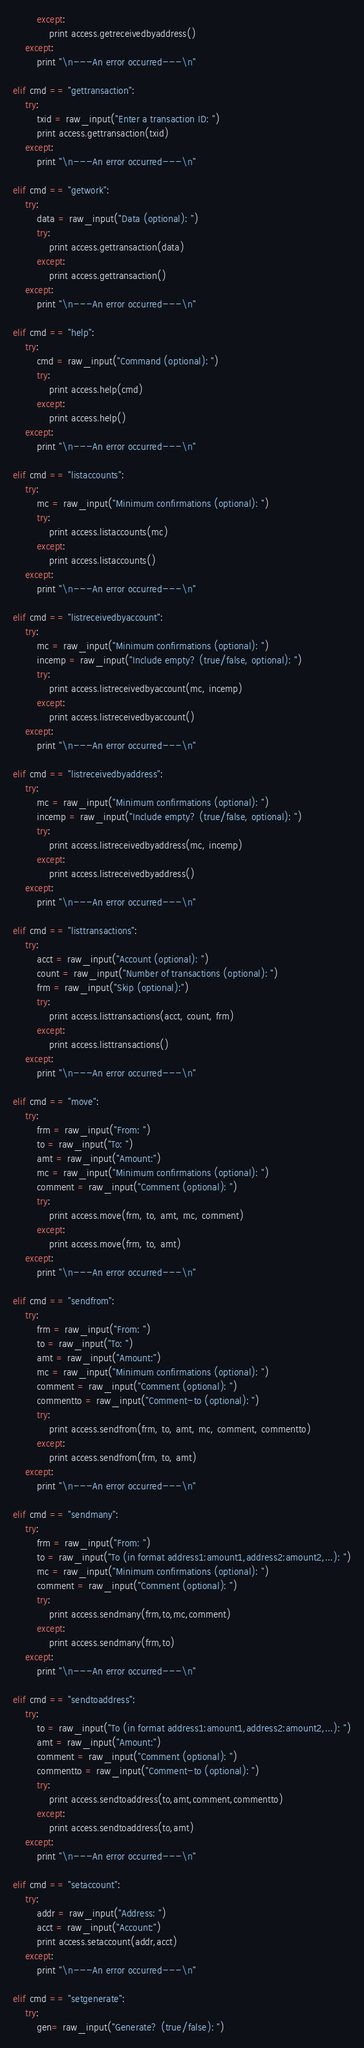Convert code to text. <code><loc_0><loc_0><loc_500><loc_500><_Python_>        except:
            print access.getreceivedbyaddress()
    except:
        print "\n---An error occurred---\n"

elif cmd == "gettransaction":
    try:
        txid = raw_input("Enter a transaction ID: ")
        print access.gettransaction(txid)
    except:
        print "\n---An error occurred---\n"

elif cmd == "getwork":
    try:
        data = raw_input("Data (optional): ")
        try:
            print access.gettransaction(data)
        except:
            print access.gettransaction()
    except:
        print "\n---An error occurred---\n"

elif cmd == "help":
    try:
        cmd = raw_input("Command (optional): ")
        try:
            print access.help(cmd)
        except:
            print access.help()
    except:
        print "\n---An error occurred---\n"

elif cmd == "listaccounts":
    try:
        mc = raw_input("Minimum confirmations (optional): ")
        try:
            print access.listaccounts(mc)
        except:
            print access.listaccounts()
    except:
        print "\n---An error occurred---\n"

elif cmd == "listreceivedbyaccount":
    try:
        mc = raw_input("Minimum confirmations (optional): ")
        incemp = raw_input("Include empty? (true/false, optional): ")
        try:
            print access.listreceivedbyaccount(mc, incemp)
        except:
            print access.listreceivedbyaccount()
    except:
        print "\n---An error occurred---\n"

elif cmd == "listreceivedbyaddress":
    try:
        mc = raw_input("Minimum confirmations (optional): ")
        incemp = raw_input("Include empty? (true/false, optional): ")
        try:
            print access.listreceivedbyaddress(mc, incemp)
        except:
            print access.listreceivedbyaddress()
    except:
        print "\n---An error occurred---\n"

elif cmd == "listtransactions":
    try:
        acct = raw_input("Account (optional): ")
        count = raw_input("Number of transactions (optional): ")
        frm = raw_input("Skip (optional):")
        try:
            print access.listtransactions(acct, count, frm)
        except:
            print access.listtransactions()
    except:
        print "\n---An error occurred---\n"

elif cmd == "move":
    try:
        frm = raw_input("From: ")
        to = raw_input("To: ")
        amt = raw_input("Amount:")
        mc = raw_input("Minimum confirmations (optional): ")
        comment = raw_input("Comment (optional): ")
        try:
            print access.move(frm, to, amt, mc, comment)
        except:
            print access.move(frm, to, amt)
    except:
        print "\n---An error occurred---\n"

elif cmd == "sendfrom":
    try:
        frm = raw_input("From: ")
        to = raw_input("To: ")
        amt = raw_input("Amount:")
        mc = raw_input("Minimum confirmations (optional): ")
        comment = raw_input("Comment (optional): ")
        commentto = raw_input("Comment-to (optional): ")
        try:
            print access.sendfrom(frm, to, amt, mc, comment, commentto)
        except:
            print access.sendfrom(frm, to, amt)
    except:
        print "\n---An error occurred---\n"

elif cmd == "sendmany":
    try:
        frm = raw_input("From: ")
        to = raw_input("To (in format address1:amount1,address2:amount2,...): ")
        mc = raw_input("Minimum confirmations (optional): ")
        comment = raw_input("Comment (optional): ")
        try:
            print access.sendmany(frm,to,mc,comment)
        except:
            print access.sendmany(frm,to)
    except:
        print "\n---An error occurred---\n"

elif cmd == "sendtoaddress":
    try:
        to = raw_input("To (in format address1:amount1,address2:amount2,...): ")
        amt = raw_input("Amount:")
        comment = raw_input("Comment (optional): ")
        commentto = raw_input("Comment-to (optional): ")
        try:
            print access.sendtoaddress(to,amt,comment,commentto)
        except:
            print access.sendtoaddress(to,amt)
    except:
        print "\n---An error occurred---\n"

elif cmd == "setaccount":
    try:
        addr = raw_input("Address: ")
        acct = raw_input("Account:")
        print access.setaccount(addr,acct)
    except:
        print "\n---An error occurred---\n"

elif cmd == "setgenerate":
    try:
        gen= raw_input("Generate? (true/false): ")</code> 